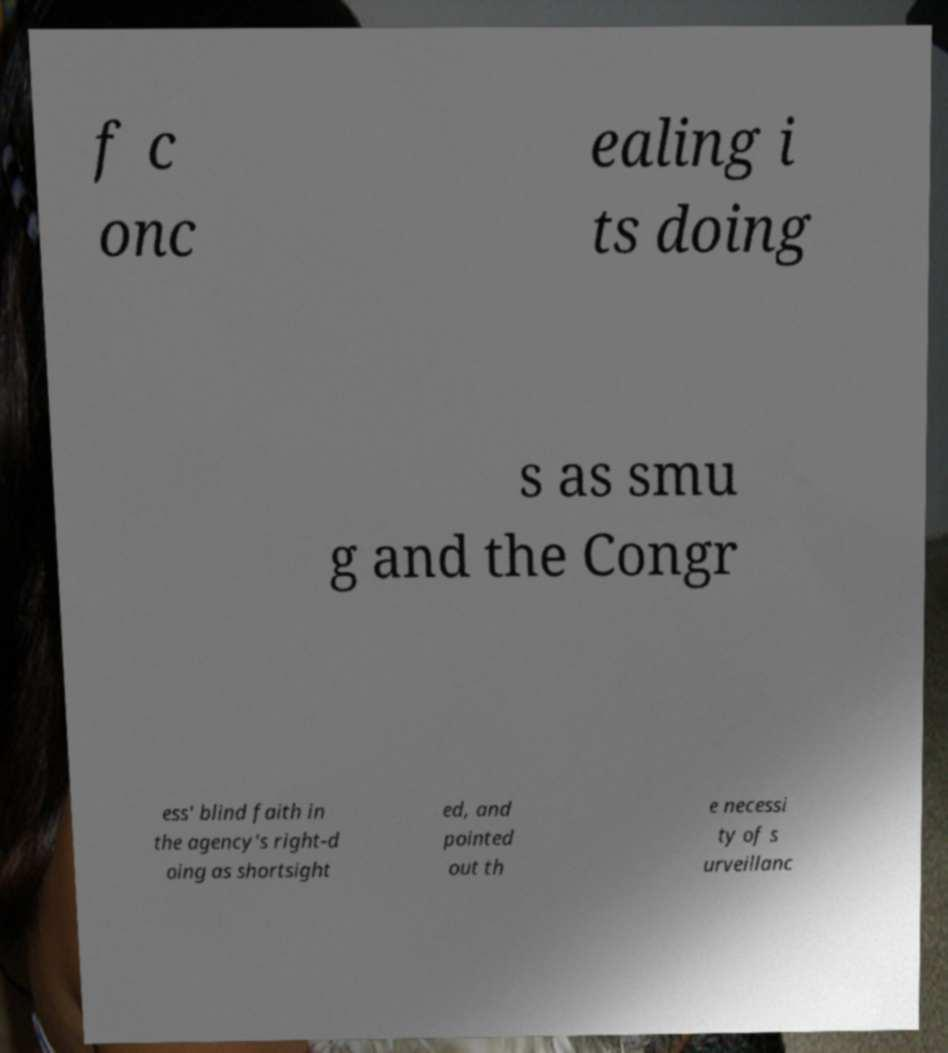I need the written content from this picture converted into text. Can you do that? f c onc ealing i ts doing s as smu g and the Congr ess' blind faith in the agency's right-d oing as shortsight ed, and pointed out th e necessi ty of s urveillanc 